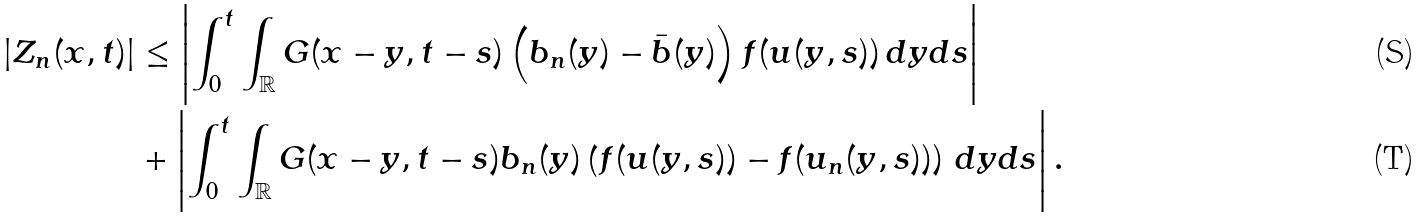<formula> <loc_0><loc_0><loc_500><loc_500>| Z _ { n } ( x , t ) | & \leq \left | \int _ { 0 } ^ { t } \int _ { \mathbb { R } } G ( x - y , t - s ) \left ( b _ { n } ( y ) - \bar { b } ( y ) \right ) f ( u ( y , s ) ) \, d y d s \right | \\ & + \left | \int _ { 0 } ^ { t } \int _ { \mathbb { R } } G ( x - y , t - s ) b _ { n } ( y ) \left ( f ( u ( y , s ) ) - f ( u _ { n } ( y , s ) ) \right ) \, d y d s \right | .</formula> 